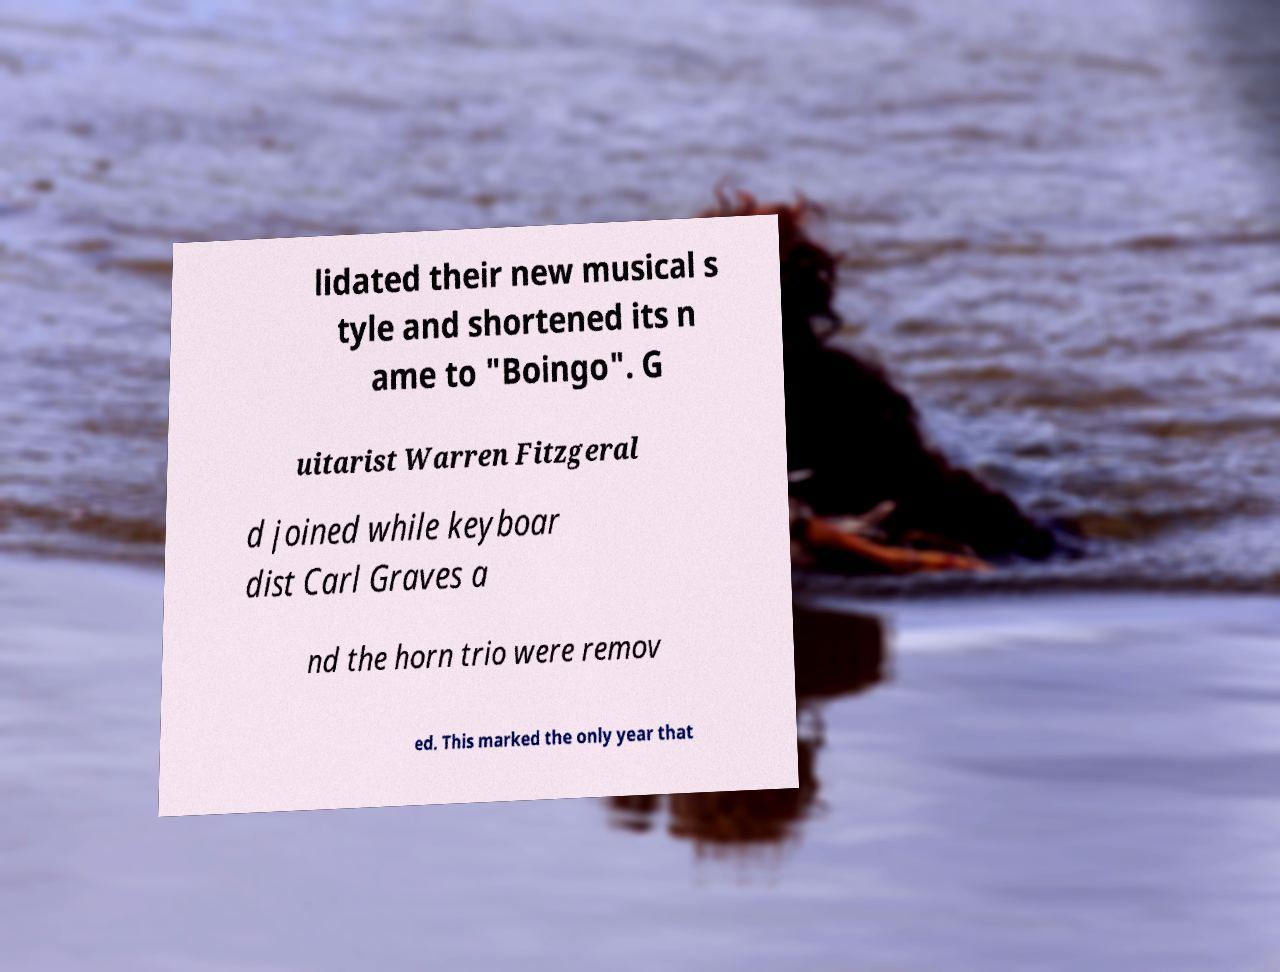Please read and relay the text visible in this image. What does it say? lidated their new musical s tyle and shortened its n ame to "Boingo". G uitarist Warren Fitzgeral d joined while keyboar dist Carl Graves a nd the horn trio were remov ed. This marked the only year that 